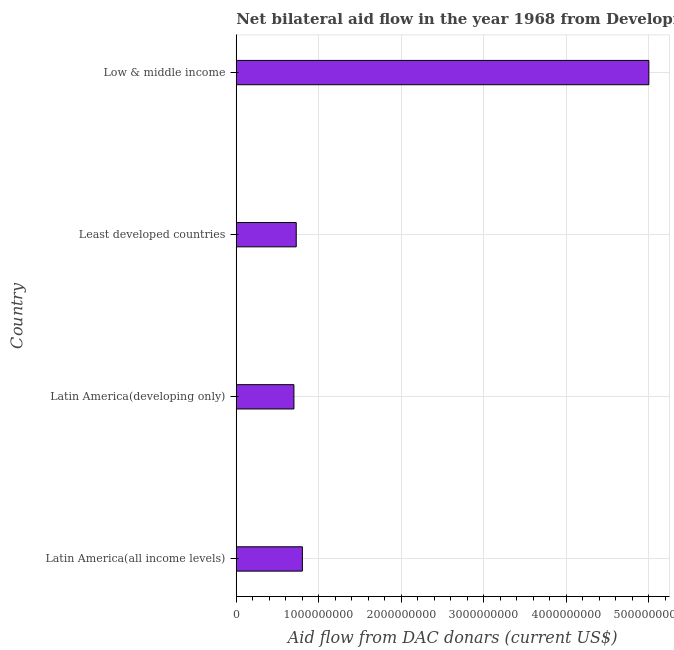Does the graph contain grids?
Make the answer very short. Yes. What is the title of the graph?
Ensure brevity in your answer.  Net bilateral aid flow in the year 1968 from Development Assistance Committee. What is the label or title of the X-axis?
Keep it short and to the point. Aid flow from DAC donars (current US$). What is the label or title of the Y-axis?
Ensure brevity in your answer.  Country. What is the net bilateral aid flows from dac donors in Latin America(all income levels)?
Your answer should be very brief. 8.02e+08. Across all countries, what is the maximum net bilateral aid flows from dac donors?
Give a very brief answer. 5.00e+09. Across all countries, what is the minimum net bilateral aid flows from dac donors?
Offer a very short reply. 6.99e+08. In which country was the net bilateral aid flows from dac donors minimum?
Offer a terse response. Latin America(developing only). What is the sum of the net bilateral aid flows from dac donors?
Your answer should be very brief. 7.23e+09. What is the difference between the net bilateral aid flows from dac donors in Latin America(developing only) and Low & middle income?
Provide a succinct answer. -4.30e+09. What is the average net bilateral aid flows from dac donors per country?
Offer a terse response. 1.81e+09. What is the median net bilateral aid flows from dac donors?
Keep it short and to the point. 7.64e+08. In how many countries, is the net bilateral aid flows from dac donors greater than 2600000000 US$?
Offer a terse response. 1. What is the ratio of the net bilateral aid flows from dac donors in Least developed countries to that in Low & middle income?
Provide a short and direct response. 0.14. Is the net bilateral aid flows from dac donors in Least developed countries less than that in Low & middle income?
Offer a terse response. Yes. What is the difference between the highest and the second highest net bilateral aid flows from dac donors?
Your answer should be very brief. 4.20e+09. Is the sum of the net bilateral aid flows from dac donors in Least developed countries and Low & middle income greater than the maximum net bilateral aid flows from dac donors across all countries?
Your answer should be compact. Yes. What is the difference between the highest and the lowest net bilateral aid flows from dac donors?
Give a very brief answer. 4.30e+09. How many countries are there in the graph?
Keep it short and to the point. 4. Are the values on the major ticks of X-axis written in scientific E-notation?
Provide a succinct answer. No. What is the Aid flow from DAC donars (current US$) of Latin America(all income levels)?
Your response must be concise. 8.02e+08. What is the Aid flow from DAC donars (current US$) of Latin America(developing only)?
Offer a terse response. 6.99e+08. What is the Aid flow from DAC donars (current US$) in Least developed countries?
Your answer should be compact. 7.27e+08. What is the Aid flow from DAC donars (current US$) of Low & middle income?
Make the answer very short. 5.00e+09. What is the difference between the Aid flow from DAC donars (current US$) in Latin America(all income levels) and Latin America(developing only)?
Make the answer very short. 1.03e+08. What is the difference between the Aid flow from DAC donars (current US$) in Latin America(all income levels) and Least developed countries?
Provide a succinct answer. 7.45e+07. What is the difference between the Aid flow from DAC donars (current US$) in Latin America(all income levels) and Low & middle income?
Provide a short and direct response. -4.20e+09. What is the difference between the Aid flow from DAC donars (current US$) in Latin America(developing only) and Least developed countries?
Your answer should be very brief. -2.80e+07. What is the difference between the Aid flow from DAC donars (current US$) in Latin America(developing only) and Low & middle income?
Provide a short and direct response. -4.30e+09. What is the difference between the Aid flow from DAC donars (current US$) in Least developed countries and Low & middle income?
Your answer should be compact. -4.28e+09. What is the ratio of the Aid flow from DAC donars (current US$) in Latin America(all income levels) to that in Latin America(developing only)?
Provide a short and direct response. 1.15. What is the ratio of the Aid flow from DAC donars (current US$) in Latin America(all income levels) to that in Least developed countries?
Offer a terse response. 1.1. What is the ratio of the Aid flow from DAC donars (current US$) in Latin America(all income levels) to that in Low & middle income?
Your answer should be compact. 0.16. What is the ratio of the Aid flow from DAC donars (current US$) in Latin America(developing only) to that in Least developed countries?
Ensure brevity in your answer.  0.96. What is the ratio of the Aid flow from DAC donars (current US$) in Latin America(developing only) to that in Low & middle income?
Your answer should be very brief. 0.14. What is the ratio of the Aid flow from DAC donars (current US$) in Least developed countries to that in Low & middle income?
Your answer should be very brief. 0.14. 